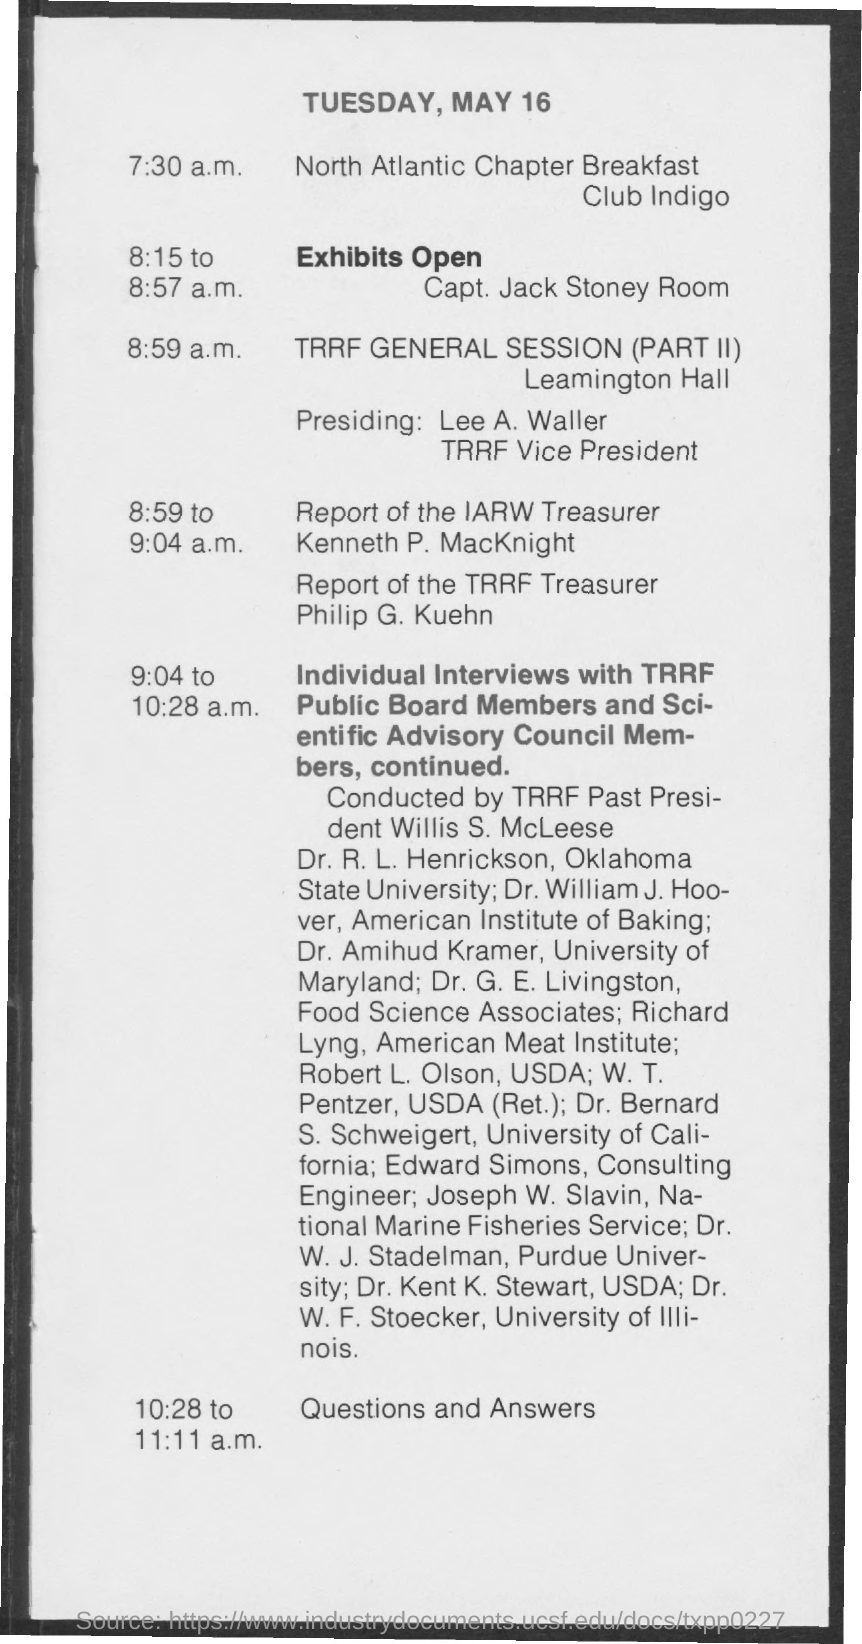Who is the Past President of TRRF?
Ensure brevity in your answer.  Willis S. McLeese. What is the designation of Edward Simons?
Your answer should be compact. Consulting Engineer. Who is Presiding the Session?
Your answer should be compact. Lee a. waller. Who is the Vice President of TRRF?
Offer a very short reply. Lee a. waller. 